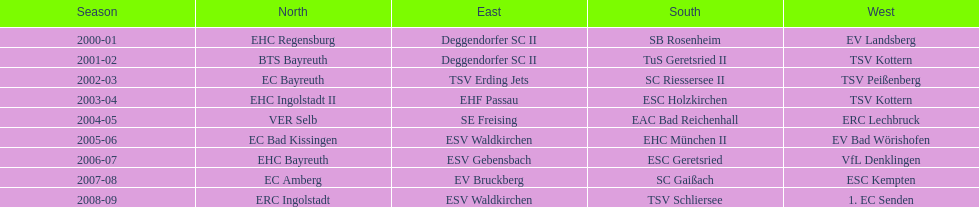What is the number of times deggendorfer sc ii is on the list? 2. 